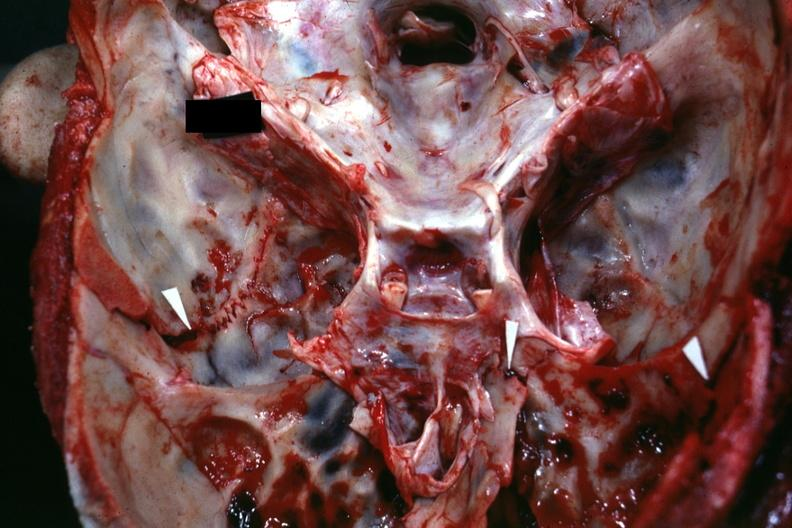does this image show close-up view of base of skull with several well shown fractures?
Answer the question using a single word or phrase. Yes 